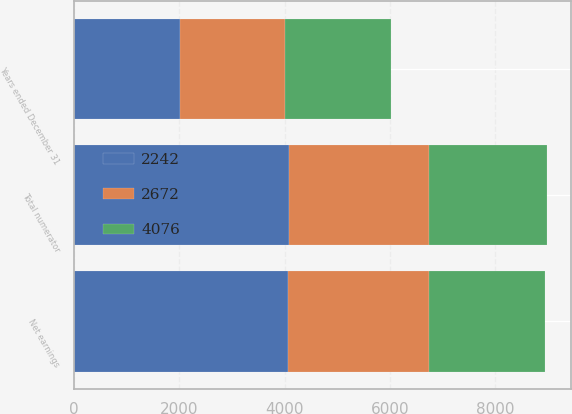Convert chart to OTSL. <chart><loc_0><loc_0><loc_500><loc_500><stacked_bar_chart><ecel><fcel>Years ended December 31<fcel>Net earnings<fcel>Total numerator<nl><fcel>2672<fcel>2008<fcel>2672<fcel>2672<nl><fcel>2242<fcel>2007<fcel>4074<fcel>4076<nl><fcel>4076<fcel>2006<fcel>2215<fcel>2242<nl></chart> 